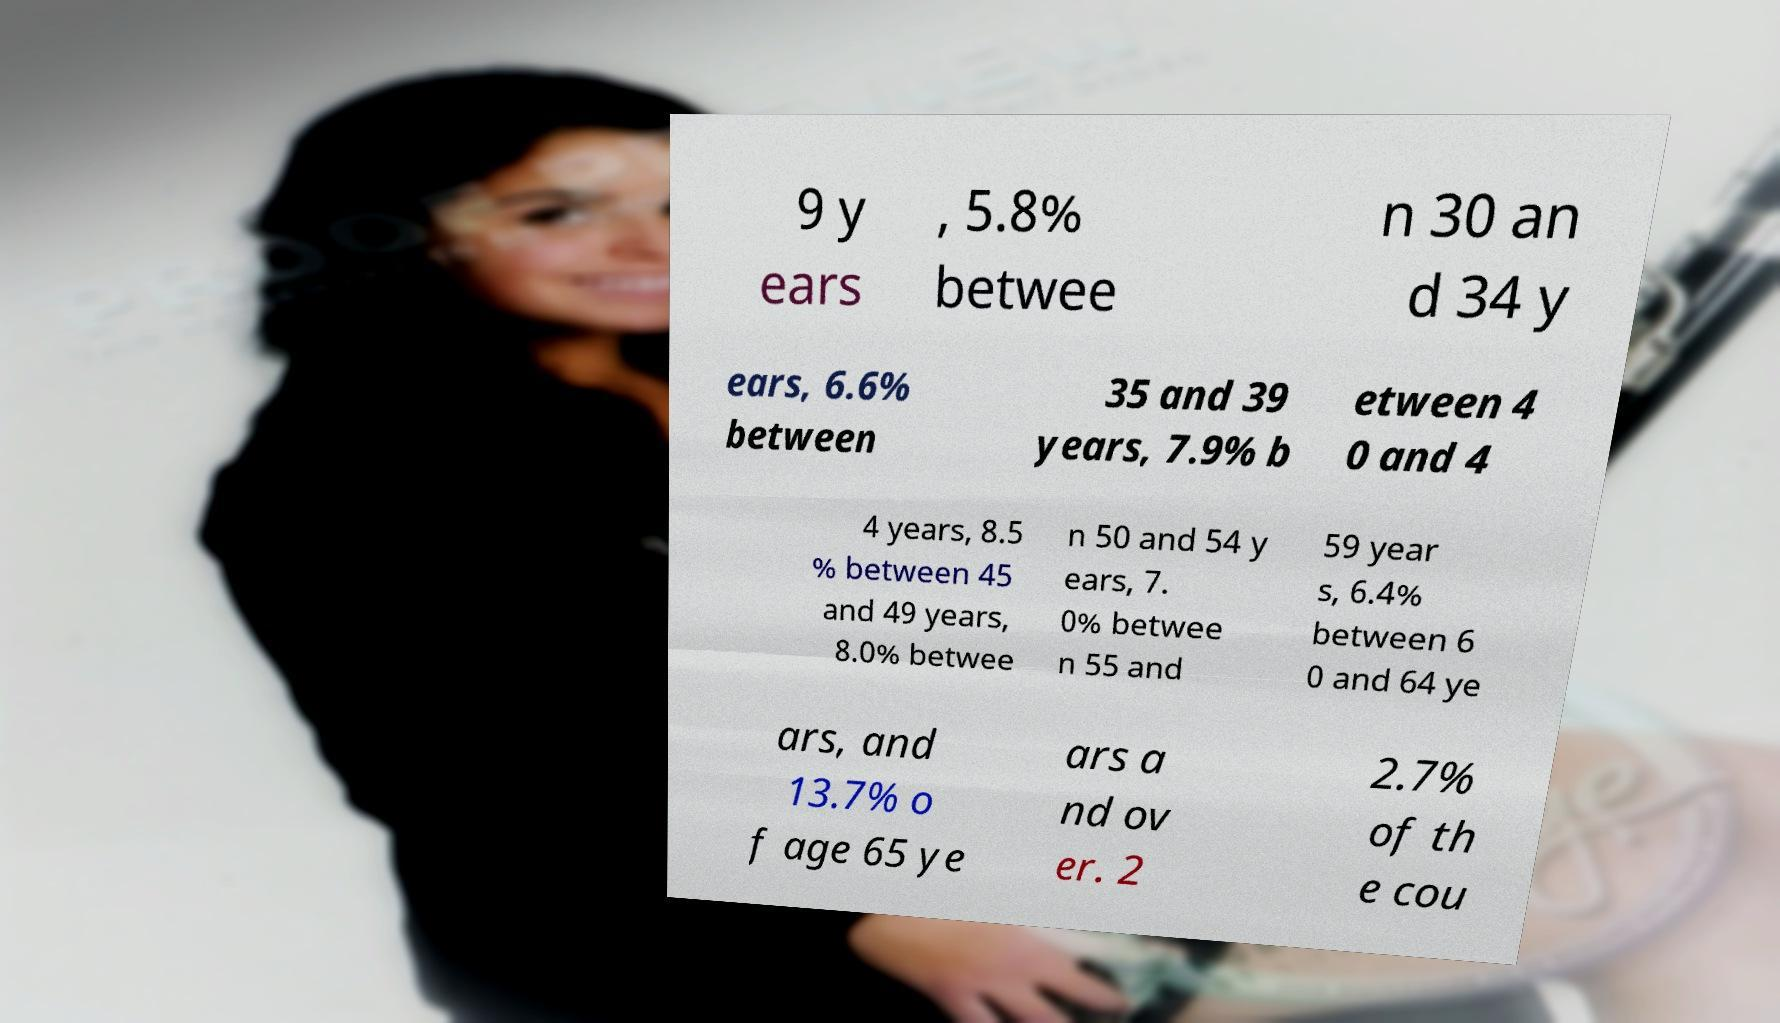I need the written content from this picture converted into text. Can you do that? 9 y ears , 5.8% betwee n 30 an d 34 y ears, 6.6% between 35 and 39 years, 7.9% b etween 4 0 and 4 4 years, 8.5 % between 45 and 49 years, 8.0% betwee n 50 and 54 y ears, 7. 0% betwee n 55 and 59 year s, 6.4% between 6 0 and 64 ye ars, and 13.7% o f age 65 ye ars a nd ov er. 2 2.7% of th e cou 